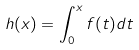Convert formula to latex. <formula><loc_0><loc_0><loc_500><loc_500>h ( x ) = \int _ { 0 } ^ { x } f ( t ) d t</formula> 